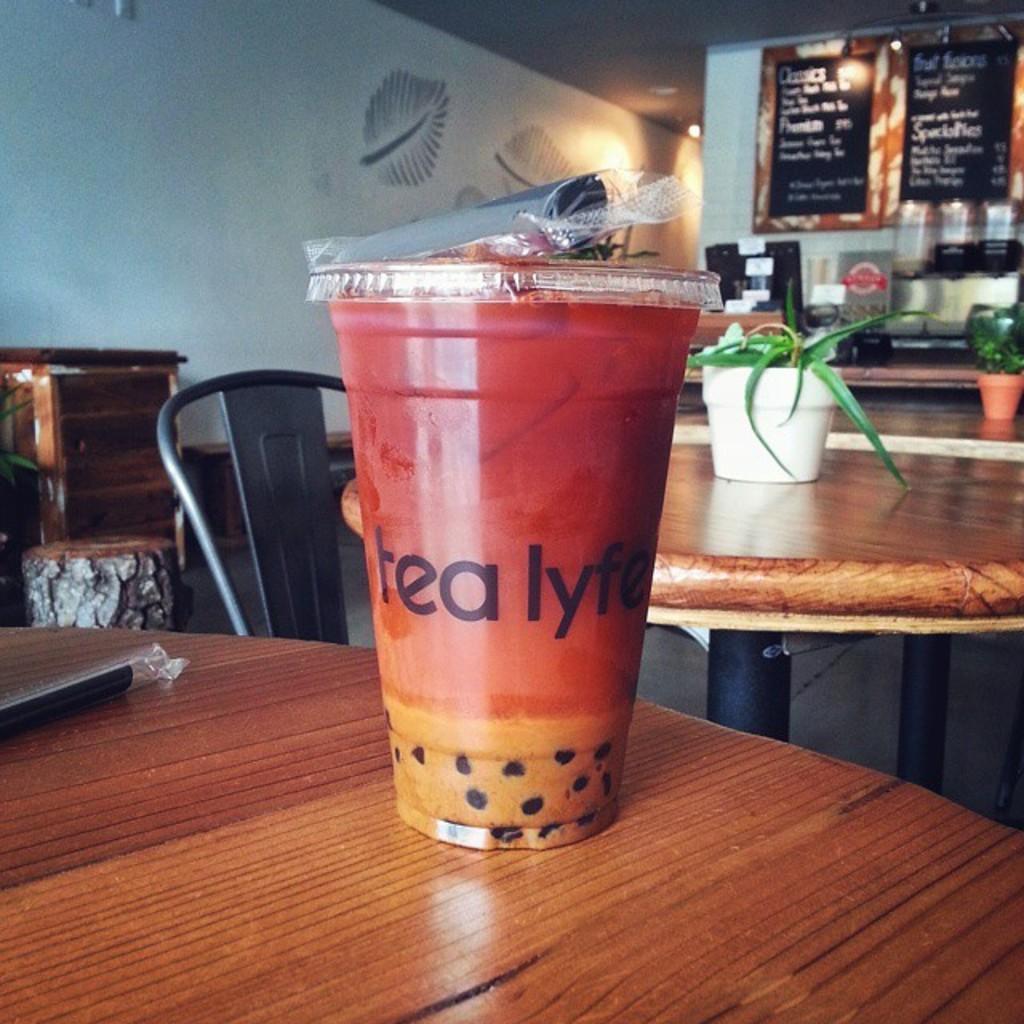Can you describe this image briefly? In the image we can see there is a table on which there is juice glass and on the other table there is a vase in which there is a plant and at the back on the wall there are blackboards on which menu is written and the wall is in white colour and in front of table there is a chair which is in ash colour. 